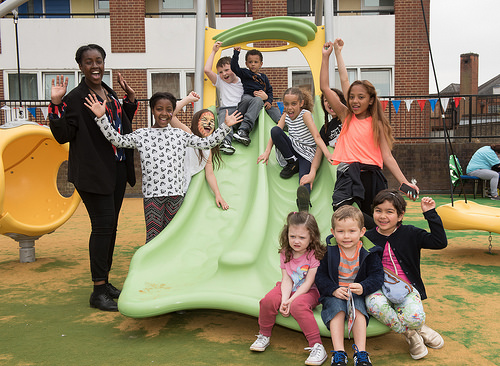<image>
Is there a toddler on the slide? Yes. Looking at the image, I can see the toddler is positioned on top of the slide, with the slide providing support. Is the girl on the slide? No. The girl is not positioned on the slide. They may be near each other, but the girl is not supported by or resting on top of the slide. 